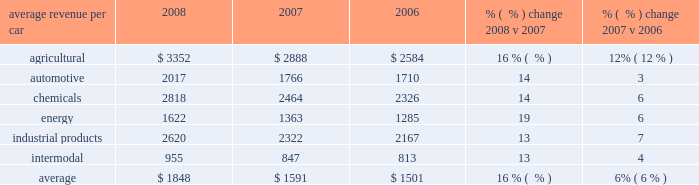Average revenue per car 2008 2007 2006 % (  % ) change 2008 v 2007 % (  % ) change 2007 v 2006 .
Agricultural products 2013 price improvements , fuel surcharges , and volume growth generated higher agricultural freight revenue in 2008 versus 2007 .
Strong global demand for grain and a weak dollar drove higher shipments of corn and feed grains and shipments of wheat and food grains for 2008 .
Shipments of ethanol , a grain product used as an alternative fuel and fuel additive , and its co- products ( primarily livestock feed ) also increased .
Price increases were the primary drivers of agricultural freight revenue in 2007 versus 2006 , partially offset by a decline in volume levels .
Shipments of whole grains used in feed declined as barge operators captured more shipments destined for export from the gulf coast due to both favorable barge rates and improved navigation conditions on the mississippi river .
Conversely , wheat and food grain shipments improved as a strong wheat crop generated record shipments to the gulf coast for export .
Shipments of ethanol and its co-products also increased substantially .
Automotive 2013 double-digit declines in shipments of both finished vehicles and auto parts drove freight revenue lower in 2008 compared to 2007 .
Price improvements and fuel surcharges partially offset these lower volumes .
The manufacturers experienced poor sales and reduced vehicle production during 2008 due to the recessionary economy , which in turn reduced shipments of finished vehicles and parts .
In addition , a major parts supplier strike reduced volume levels compared to 2007 .
Shipments of finished vehicles decreased 23% ( 23 % ) in 2008 versus 2007 .
In 2007 , price increases drove the growth in automotive revenue , partially offset by lower finished vehicle shipments versus 2006 .
A decline in vehicle production levels primarily drove the volume decline .
Conversely , automotive parts shipments grew due to increased volumes from domestic manufacturers , new business acquired in the middle of 2006 , and our new intermodal train service between mexico and michigan .
2008 agricultural revenue 2008 automotive revenue .
In 2008 what was the ratio of the average revenue per car for the agriculture products to energy? 
Computations: (3352 / 1622)
Answer: 2.06658. 